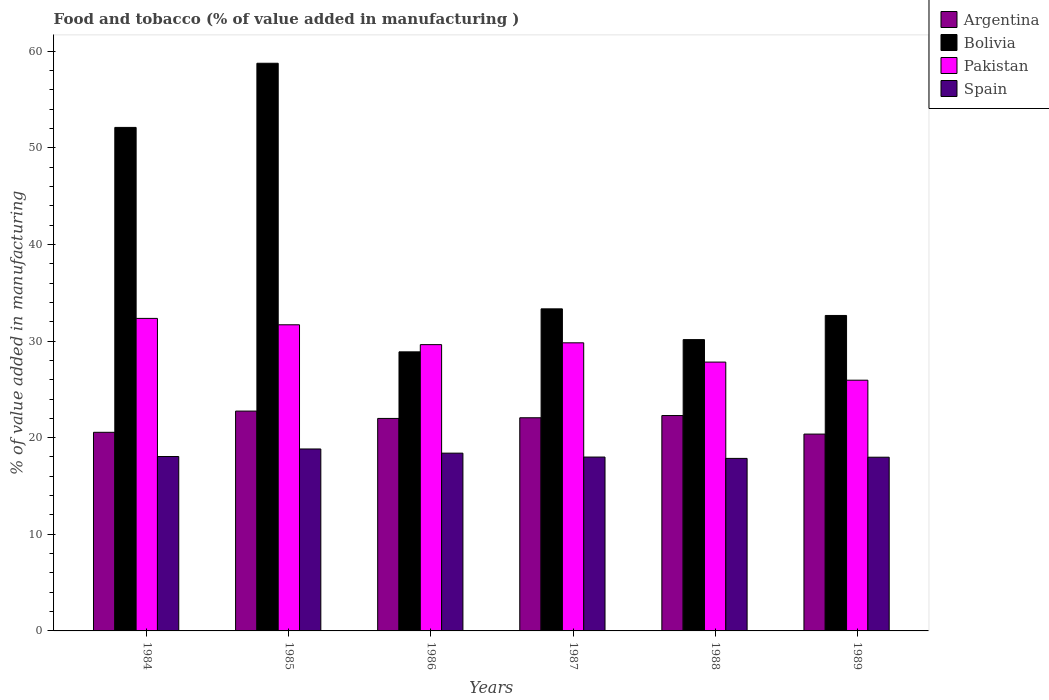How many groups of bars are there?
Give a very brief answer. 6. Are the number of bars per tick equal to the number of legend labels?
Offer a very short reply. Yes. Are the number of bars on each tick of the X-axis equal?
Keep it short and to the point. Yes. How many bars are there on the 5th tick from the left?
Offer a terse response. 4. How many bars are there on the 5th tick from the right?
Offer a very short reply. 4. What is the value added in manufacturing food and tobacco in Bolivia in 1986?
Keep it short and to the point. 28.88. Across all years, what is the maximum value added in manufacturing food and tobacco in Bolivia?
Offer a terse response. 58.75. Across all years, what is the minimum value added in manufacturing food and tobacco in Argentina?
Keep it short and to the point. 20.37. What is the total value added in manufacturing food and tobacco in Bolivia in the graph?
Provide a short and direct response. 235.86. What is the difference between the value added in manufacturing food and tobacco in Argentina in 1984 and that in 1986?
Give a very brief answer. -1.44. What is the difference between the value added in manufacturing food and tobacco in Argentina in 1988 and the value added in manufacturing food and tobacco in Pakistan in 1984?
Your response must be concise. -10.05. What is the average value added in manufacturing food and tobacco in Argentina per year?
Ensure brevity in your answer.  21.67. In the year 1986, what is the difference between the value added in manufacturing food and tobacco in Pakistan and value added in manufacturing food and tobacco in Argentina?
Your answer should be compact. 7.64. In how many years, is the value added in manufacturing food and tobacco in Spain greater than 20 %?
Your answer should be compact. 0. What is the ratio of the value added in manufacturing food and tobacco in Spain in 1985 to that in 1986?
Ensure brevity in your answer.  1.02. Is the value added in manufacturing food and tobacco in Argentina in 1988 less than that in 1989?
Offer a very short reply. No. What is the difference between the highest and the second highest value added in manufacturing food and tobacco in Pakistan?
Your response must be concise. 0.66. What is the difference between the highest and the lowest value added in manufacturing food and tobacco in Bolivia?
Offer a very short reply. 29.87. Is the sum of the value added in manufacturing food and tobacco in Spain in 1984 and 1986 greater than the maximum value added in manufacturing food and tobacco in Bolivia across all years?
Provide a short and direct response. No. Is it the case that in every year, the sum of the value added in manufacturing food and tobacco in Argentina and value added in manufacturing food and tobacco in Pakistan is greater than the sum of value added in manufacturing food and tobacco in Spain and value added in manufacturing food and tobacco in Bolivia?
Offer a terse response. Yes. What does the 4th bar from the right in 1988 represents?
Keep it short and to the point. Argentina. How many bars are there?
Your answer should be compact. 24. Are all the bars in the graph horizontal?
Ensure brevity in your answer.  No. Does the graph contain grids?
Your answer should be compact. No. Where does the legend appear in the graph?
Your answer should be compact. Top right. How many legend labels are there?
Your answer should be very brief. 4. How are the legend labels stacked?
Your response must be concise. Vertical. What is the title of the graph?
Offer a very short reply. Food and tobacco (% of value added in manufacturing ). Does "Somalia" appear as one of the legend labels in the graph?
Your answer should be very brief. No. What is the label or title of the X-axis?
Keep it short and to the point. Years. What is the label or title of the Y-axis?
Offer a very short reply. % of value added in manufacturing. What is the % of value added in manufacturing in Argentina in 1984?
Provide a short and direct response. 20.55. What is the % of value added in manufacturing of Bolivia in 1984?
Offer a terse response. 52.11. What is the % of value added in manufacturing in Pakistan in 1984?
Your response must be concise. 32.34. What is the % of value added in manufacturing of Spain in 1984?
Offer a terse response. 18.05. What is the % of value added in manufacturing of Argentina in 1985?
Offer a very short reply. 22.75. What is the % of value added in manufacturing in Bolivia in 1985?
Make the answer very short. 58.75. What is the % of value added in manufacturing of Pakistan in 1985?
Provide a short and direct response. 31.68. What is the % of value added in manufacturing of Spain in 1985?
Offer a very short reply. 18.83. What is the % of value added in manufacturing in Argentina in 1986?
Ensure brevity in your answer.  21.99. What is the % of value added in manufacturing of Bolivia in 1986?
Give a very brief answer. 28.88. What is the % of value added in manufacturing of Pakistan in 1986?
Your answer should be very brief. 29.63. What is the % of value added in manufacturing in Spain in 1986?
Offer a terse response. 18.4. What is the % of value added in manufacturing of Argentina in 1987?
Keep it short and to the point. 22.06. What is the % of value added in manufacturing in Bolivia in 1987?
Give a very brief answer. 33.33. What is the % of value added in manufacturing of Pakistan in 1987?
Your answer should be compact. 29.82. What is the % of value added in manufacturing of Spain in 1987?
Keep it short and to the point. 17.99. What is the % of value added in manufacturing of Argentina in 1988?
Your answer should be very brief. 22.29. What is the % of value added in manufacturing of Bolivia in 1988?
Offer a terse response. 30.15. What is the % of value added in manufacturing of Pakistan in 1988?
Provide a succinct answer. 27.82. What is the % of value added in manufacturing in Spain in 1988?
Provide a short and direct response. 17.85. What is the % of value added in manufacturing in Argentina in 1989?
Offer a very short reply. 20.37. What is the % of value added in manufacturing in Bolivia in 1989?
Provide a short and direct response. 32.65. What is the % of value added in manufacturing of Pakistan in 1989?
Give a very brief answer. 25.95. What is the % of value added in manufacturing of Spain in 1989?
Give a very brief answer. 17.98. Across all years, what is the maximum % of value added in manufacturing of Argentina?
Offer a very short reply. 22.75. Across all years, what is the maximum % of value added in manufacturing of Bolivia?
Your response must be concise. 58.75. Across all years, what is the maximum % of value added in manufacturing of Pakistan?
Offer a very short reply. 32.34. Across all years, what is the maximum % of value added in manufacturing of Spain?
Your response must be concise. 18.83. Across all years, what is the minimum % of value added in manufacturing in Argentina?
Provide a succinct answer. 20.37. Across all years, what is the minimum % of value added in manufacturing in Bolivia?
Your answer should be very brief. 28.88. Across all years, what is the minimum % of value added in manufacturing of Pakistan?
Offer a very short reply. 25.95. Across all years, what is the minimum % of value added in manufacturing of Spain?
Provide a succinct answer. 17.85. What is the total % of value added in manufacturing of Argentina in the graph?
Your response must be concise. 130.01. What is the total % of value added in manufacturing in Bolivia in the graph?
Make the answer very short. 235.86. What is the total % of value added in manufacturing in Pakistan in the graph?
Ensure brevity in your answer.  177.24. What is the total % of value added in manufacturing in Spain in the graph?
Your answer should be very brief. 109.1. What is the difference between the % of value added in manufacturing in Argentina in 1984 and that in 1985?
Offer a very short reply. -2.2. What is the difference between the % of value added in manufacturing in Bolivia in 1984 and that in 1985?
Keep it short and to the point. -6.64. What is the difference between the % of value added in manufacturing in Pakistan in 1984 and that in 1985?
Provide a short and direct response. 0.66. What is the difference between the % of value added in manufacturing of Spain in 1984 and that in 1985?
Provide a succinct answer. -0.78. What is the difference between the % of value added in manufacturing of Argentina in 1984 and that in 1986?
Offer a terse response. -1.44. What is the difference between the % of value added in manufacturing in Bolivia in 1984 and that in 1986?
Offer a terse response. 23.23. What is the difference between the % of value added in manufacturing in Pakistan in 1984 and that in 1986?
Provide a short and direct response. 2.72. What is the difference between the % of value added in manufacturing of Spain in 1984 and that in 1986?
Provide a short and direct response. -0.35. What is the difference between the % of value added in manufacturing in Argentina in 1984 and that in 1987?
Make the answer very short. -1.51. What is the difference between the % of value added in manufacturing in Bolivia in 1984 and that in 1987?
Make the answer very short. 18.78. What is the difference between the % of value added in manufacturing in Pakistan in 1984 and that in 1987?
Keep it short and to the point. 2.53. What is the difference between the % of value added in manufacturing of Spain in 1984 and that in 1987?
Provide a succinct answer. 0.05. What is the difference between the % of value added in manufacturing of Argentina in 1984 and that in 1988?
Give a very brief answer. -1.74. What is the difference between the % of value added in manufacturing in Bolivia in 1984 and that in 1988?
Provide a succinct answer. 21.96. What is the difference between the % of value added in manufacturing in Pakistan in 1984 and that in 1988?
Make the answer very short. 4.52. What is the difference between the % of value added in manufacturing of Spain in 1984 and that in 1988?
Your response must be concise. 0.19. What is the difference between the % of value added in manufacturing in Argentina in 1984 and that in 1989?
Make the answer very short. 0.18. What is the difference between the % of value added in manufacturing in Bolivia in 1984 and that in 1989?
Your answer should be compact. 19.46. What is the difference between the % of value added in manufacturing in Pakistan in 1984 and that in 1989?
Provide a succinct answer. 6.39. What is the difference between the % of value added in manufacturing in Spain in 1984 and that in 1989?
Ensure brevity in your answer.  0.07. What is the difference between the % of value added in manufacturing of Argentina in 1985 and that in 1986?
Provide a succinct answer. 0.76. What is the difference between the % of value added in manufacturing of Bolivia in 1985 and that in 1986?
Your response must be concise. 29.87. What is the difference between the % of value added in manufacturing of Pakistan in 1985 and that in 1986?
Your response must be concise. 2.05. What is the difference between the % of value added in manufacturing in Spain in 1985 and that in 1986?
Make the answer very short. 0.43. What is the difference between the % of value added in manufacturing in Argentina in 1985 and that in 1987?
Offer a very short reply. 0.69. What is the difference between the % of value added in manufacturing of Bolivia in 1985 and that in 1987?
Offer a very short reply. 25.42. What is the difference between the % of value added in manufacturing in Pakistan in 1985 and that in 1987?
Provide a succinct answer. 1.87. What is the difference between the % of value added in manufacturing in Spain in 1985 and that in 1987?
Keep it short and to the point. 0.84. What is the difference between the % of value added in manufacturing in Argentina in 1985 and that in 1988?
Your response must be concise. 0.46. What is the difference between the % of value added in manufacturing of Bolivia in 1985 and that in 1988?
Ensure brevity in your answer.  28.6. What is the difference between the % of value added in manufacturing in Pakistan in 1985 and that in 1988?
Provide a succinct answer. 3.86. What is the difference between the % of value added in manufacturing in Spain in 1985 and that in 1988?
Give a very brief answer. 0.97. What is the difference between the % of value added in manufacturing in Argentina in 1985 and that in 1989?
Give a very brief answer. 2.38. What is the difference between the % of value added in manufacturing in Bolivia in 1985 and that in 1989?
Give a very brief answer. 26.1. What is the difference between the % of value added in manufacturing in Pakistan in 1985 and that in 1989?
Ensure brevity in your answer.  5.73. What is the difference between the % of value added in manufacturing of Spain in 1985 and that in 1989?
Offer a very short reply. 0.85. What is the difference between the % of value added in manufacturing in Argentina in 1986 and that in 1987?
Offer a very short reply. -0.07. What is the difference between the % of value added in manufacturing in Bolivia in 1986 and that in 1987?
Offer a terse response. -4.45. What is the difference between the % of value added in manufacturing of Pakistan in 1986 and that in 1987?
Ensure brevity in your answer.  -0.19. What is the difference between the % of value added in manufacturing of Spain in 1986 and that in 1987?
Your answer should be compact. 0.4. What is the difference between the % of value added in manufacturing of Argentina in 1986 and that in 1988?
Offer a terse response. -0.3. What is the difference between the % of value added in manufacturing in Bolivia in 1986 and that in 1988?
Offer a terse response. -1.27. What is the difference between the % of value added in manufacturing of Pakistan in 1986 and that in 1988?
Provide a succinct answer. 1.8. What is the difference between the % of value added in manufacturing of Spain in 1986 and that in 1988?
Keep it short and to the point. 0.54. What is the difference between the % of value added in manufacturing in Argentina in 1986 and that in 1989?
Offer a very short reply. 1.62. What is the difference between the % of value added in manufacturing of Bolivia in 1986 and that in 1989?
Offer a very short reply. -3.77. What is the difference between the % of value added in manufacturing of Pakistan in 1986 and that in 1989?
Offer a terse response. 3.68. What is the difference between the % of value added in manufacturing in Spain in 1986 and that in 1989?
Ensure brevity in your answer.  0.42. What is the difference between the % of value added in manufacturing of Argentina in 1987 and that in 1988?
Provide a short and direct response. -0.23. What is the difference between the % of value added in manufacturing of Bolivia in 1987 and that in 1988?
Keep it short and to the point. 3.18. What is the difference between the % of value added in manufacturing of Pakistan in 1987 and that in 1988?
Ensure brevity in your answer.  1.99. What is the difference between the % of value added in manufacturing of Spain in 1987 and that in 1988?
Your answer should be compact. 0.14. What is the difference between the % of value added in manufacturing of Argentina in 1987 and that in 1989?
Give a very brief answer. 1.69. What is the difference between the % of value added in manufacturing in Bolivia in 1987 and that in 1989?
Provide a short and direct response. 0.68. What is the difference between the % of value added in manufacturing of Pakistan in 1987 and that in 1989?
Your response must be concise. 3.87. What is the difference between the % of value added in manufacturing in Spain in 1987 and that in 1989?
Keep it short and to the point. 0.02. What is the difference between the % of value added in manufacturing in Argentina in 1988 and that in 1989?
Your response must be concise. 1.92. What is the difference between the % of value added in manufacturing in Bolivia in 1988 and that in 1989?
Your answer should be very brief. -2.5. What is the difference between the % of value added in manufacturing in Pakistan in 1988 and that in 1989?
Offer a terse response. 1.87. What is the difference between the % of value added in manufacturing of Spain in 1988 and that in 1989?
Offer a very short reply. -0.12. What is the difference between the % of value added in manufacturing in Argentina in 1984 and the % of value added in manufacturing in Bolivia in 1985?
Give a very brief answer. -38.19. What is the difference between the % of value added in manufacturing of Argentina in 1984 and the % of value added in manufacturing of Pakistan in 1985?
Your answer should be very brief. -11.13. What is the difference between the % of value added in manufacturing of Argentina in 1984 and the % of value added in manufacturing of Spain in 1985?
Your answer should be compact. 1.73. What is the difference between the % of value added in manufacturing in Bolivia in 1984 and the % of value added in manufacturing in Pakistan in 1985?
Offer a terse response. 20.43. What is the difference between the % of value added in manufacturing in Bolivia in 1984 and the % of value added in manufacturing in Spain in 1985?
Your response must be concise. 33.28. What is the difference between the % of value added in manufacturing of Pakistan in 1984 and the % of value added in manufacturing of Spain in 1985?
Provide a succinct answer. 13.51. What is the difference between the % of value added in manufacturing in Argentina in 1984 and the % of value added in manufacturing in Bolivia in 1986?
Give a very brief answer. -8.33. What is the difference between the % of value added in manufacturing of Argentina in 1984 and the % of value added in manufacturing of Pakistan in 1986?
Give a very brief answer. -9.07. What is the difference between the % of value added in manufacturing in Argentina in 1984 and the % of value added in manufacturing in Spain in 1986?
Keep it short and to the point. 2.16. What is the difference between the % of value added in manufacturing in Bolivia in 1984 and the % of value added in manufacturing in Pakistan in 1986?
Your answer should be compact. 22.48. What is the difference between the % of value added in manufacturing of Bolivia in 1984 and the % of value added in manufacturing of Spain in 1986?
Your answer should be very brief. 33.71. What is the difference between the % of value added in manufacturing of Pakistan in 1984 and the % of value added in manufacturing of Spain in 1986?
Your response must be concise. 13.94. What is the difference between the % of value added in manufacturing in Argentina in 1984 and the % of value added in manufacturing in Bolivia in 1987?
Provide a short and direct response. -12.78. What is the difference between the % of value added in manufacturing of Argentina in 1984 and the % of value added in manufacturing of Pakistan in 1987?
Give a very brief answer. -9.26. What is the difference between the % of value added in manufacturing of Argentina in 1984 and the % of value added in manufacturing of Spain in 1987?
Make the answer very short. 2.56. What is the difference between the % of value added in manufacturing of Bolivia in 1984 and the % of value added in manufacturing of Pakistan in 1987?
Your answer should be very brief. 22.29. What is the difference between the % of value added in manufacturing of Bolivia in 1984 and the % of value added in manufacturing of Spain in 1987?
Your answer should be compact. 34.11. What is the difference between the % of value added in manufacturing in Pakistan in 1984 and the % of value added in manufacturing in Spain in 1987?
Make the answer very short. 14.35. What is the difference between the % of value added in manufacturing of Argentina in 1984 and the % of value added in manufacturing of Bolivia in 1988?
Ensure brevity in your answer.  -9.59. What is the difference between the % of value added in manufacturing of Argentina in 1984 and the % of value added in manufacturing of Pakistan in 1988?
Make the answer very short. -7.27. What is the difference between the % of value added in manufacturing in Argentina in 1984 and the % of value added in manufacturing in Spain in 1988?
Provide a short and direct response. 2.7. What is the difference between the % of value added in manufacturing in Bolivia in 1984 and the % of value added in manufacturing in Pakistan in 1988?
Offer a very short reply. 24.29. What is the difference between the % of value added in manufacturing in Bolivia in 1984 and the % of value added in manufacturing in Spain in 1988?
Offer a terse response. 34.25. What is the difference between the % of value added in manufacturing in Pakistan in 1984 and the % of value added in manufacturing in Spain in 1988?
Ensure brevity in your answer.  14.49. What is the difference between the % of value added in manufacturing in Argentina in 1984 and the % of value added in manufacturing in Bolivia in 1989?
Offer a terse response. -12.09. What is the difference between the % of value added in manufacturing in Argentina in 1984 and the % of value added in manufacturing in Pakistan in 1989?
Offer a terse response. -5.39. What is the difference between the % of value added in manufacturing in Argentina in 1984 and the % of value added in manufacturing in Spain in 1989?
Provide a short and direct response. 2.58. What is the difference between the % of value added in manufacturing of Bolivia in 1984 and the % of value added in manufacturing of Pakistan in 1989?
Give a very brief answer. 26.16. What is the difference between the % of value added in manufacturing in Bolivia in 1984 and the % of value added in manufacturing in Spain in 1989?
Your answer should be very brief. 34.13. What is the difference between the % of value added in manufacturing of Pakistan in 1984 and the % of value added in manufacturing of Spain in 1989?
Make the answer very short. 14.37. What is the difference between the % of value added in manufacturing in Argentina in 1985 and the % of value added in manufacturing in Bolivia in 1986?
Your response must be concise. -6.13. What is the difference between the % of value added in manufacturing in Argentina in 1985 and the % of value added in manufacturing in Pakistan in 1986?
Offer a terse response. -6.88. What is the difference between the % of value added in manufacturing of Argentina in 1985 and the % of value added in manufacturing of Spain in 1986?
Offer a very short reply. 4.35. What is the difference between the % of value added in manufacturing in Bolivia in 1985 and the % of value added in manufacturing in Pakistan in 1986?
Offer a terse response. 29.12. What is the difference between the % of value added in manufacturing in Bolivia in 1985 and the % of value added in manufacturing in Spain in 1986?
Your answer should be compact. 40.35. What is the difference between the % of value added in manufacturing in Pakistan in 1985 and the % of value added in manufacturing in Spain in 1986?
Your answer should be very brief. 13.28. What is the difference between the % of value added in manufacturing in Argentina in 1985 and the % of value added in manufacturing in Bolivia in 1987?
Ensure brevity in your answer.  -10.58. What is the difference between the % of value added in manufacturing in Argentina in 1985 and the % of value added in manufacturing in Pakistan in 1987?
Ensure brevity in your answer.  -7.07. What is the difference between the % of value added in manufacturing in Argentina in 1985 and the % of value added in manufacturing in Spain in 1987?
Your answer should be compact. 4.76. What is the difference between the % of value added in manufacturing in Bolivia in 1985 and the % of value added in manufacturing in Pakistan in 1987?
Your response must be concise. 28.93. What is the difference between the % of value added in manufacturing in Bolivia in 1985 and the % of value added in manufacturing in Spain in 1987?
Offer a terse response. 40.75. What is the difference between the % of value added in manufacturing of Pakistan in 1985 and the % of value added in manufacturing of Spain in 1987?
Ensure brevity in your answer.  13.69. What is the difference between the % of value added in manufacturing in Argentina in 1985 and the % of value added in manufacturing in Bolivia in 1988?
Give a very brief answer. -7.4. What is the difference between the % of value added in manufacturing in Argentina in 1985 and the % of value added in manufacturing in Pakistan in 1988?
Give a very brief answer. -5.07. What is the difference between the % of value added in manufacturing in Argentina in 1985 and the % of value added in manufacturing in Spain in 1988?
Your answer should be compact. 4.9. What is the difference between the % of value added in manufacturing in Bolivia in 1985 and the % of value added in manufacturing in Pakistan in 1988?
Your answer should be compact. 30.92. What is the difference between the % of value added in manufacturing in Bolivia in 1985 and the % of value added in manufacturing in Spain in 1988?
Provide a short and direct response. 40.89. What is the difference between the % of value added in manufacturing of Pakistan in 1985 and the % of value added in manufacturing of Spain in 1988?
Provide a short and direct response. 13.83. What is the difference between the % of value added in manufacturing in Argentina in 1985 and the % of value added in manufacturing in Bolivia in 1989?
Offer a terse response. -9.9. What is the difference between the % of value added in manufacturing of Argentina in 1985 and the % of value added in manufacturing of Pakistan in 1989?
Offer a terse response. -3.2. What is the difference between the % of value added in manufacturing of Argentina in 1985 and the % of value added in manufacturing of Spain in 1989?
Ensure brevity in your answer.  4.77. What is the difference between the % of value added in manufacturing of Bolivia in 1985 and the % of value added in manufacturing of Pakistan in 1989?
Your answer should be very brief. 32.8. What is the difference between the % of value added in manufacturing of Bolivia in 1985 and the % of value added in manufacturing of Spain in 1989?
Offer a very short reply. 40.77. What is the difference between the % of value added in manufacturing of Pakistan in 1985 and the % of value added in manufacturing of Spain in 1989?
Make the answer very short. 13.7. What is the difference between the % of value added in manufacturing of Argentina in 1986 and the % of value added in manufacturing of Bolivia in 1987?
Offer a terse response. -11.34. What is the difference between the % of value added in manufacturing in Argentina in 1986 and the % of value added in manufacturing in Pakistan in 1987?
Provide a short and direct response. -7.83. What is the difference between the % of value added in manufacturing in Argentina in 1986 and the % of value added in manufacturing in Spain in 1987?
Your answer should be compact. 4. What is the difference between the % of value added in manufacturing in Bolivia in 1986 and the % of value added in manufacturing in Pakistan in 1987?
Give a very brief answer. -0.93. What is the difference between the % of value added in manufacturing of Bolivia in 1986 and the % of value added in manufacturing of Spain in 1987?
Make the answer very short. 10.89. What is the difference between the % of value added in manufacturing of Pakistan in 1986 and the % of value added in manufacturing of Spain in 1987?
Make the answer very short. 11.63. What is the difference between the % of value added in manufacturing in Argentina in 1986 and the % of value added in manufacturing in Bolivia in 1988?
Offer a terse response. -8.16. What is the difference between the % of value added in manufacturing of Argentina in 1986 and the % of value added in manufacturing of Pakistan in 1988?
Provide a succinct answer. -5.83. What is the difference between the % of value added in manufacturing of Argentina in 1986 and the % of value added in manufacturing of Spain in 1988?
Offer a terse response. 4.14. What is the difference between the % of value added in manufacturing of Bolivia in 1986 and the % of value added in manufacturing of Pakistan in 1988?
Make the answer very short. 1.06. What is the difference between the % of value added in manufacturing of Bolivia in 1986 and the % of value added in manufacturing of Spain in 1988?
Ensure brevity in your answer.  11.03. What is the difference between the % of value added in manufacturing of Pakistan in 1986 and the % of value added in manufacturing of Spain in 1988?
Provide a short and direct response. 11.77. What is the difference between the % of value added in manufacturing of Argentina in 1986 and the % of value added in manufacturing of Bolivia in 1989?
Your answer should be very brief. -10.66. What is the difference between the % of value added in manufacturing in Argentina in 1986 and the % of value added in manufacturing in Pakistan in 1989?
Your answer should be very brief. -3.96. What is the difference between the % of value added in manufacturing of Argentina in 1986 and the % of value added in manufacturing of Spain in 1989?
Your response must be concise. 4.01. What is the difference between the % of value added in manufacturing in Bolivia in 1986 and the % of value added in manufacturing in Pakistan in 1989?
Provide a succinct answer. 2.93. What is the difference between the % of value added in manufacturing of Bolivia in 1986 and the % of value added in manufacturing of Spain in 1989?
Keep it short and to the point. 10.9. What is the difference between the % of value added in manufacturing of Pakistan in 1986 and the % of value added in manufacturing of Spain in 1989?
Provide a succinct answer. 11.65. What is the difference between the % of value added in manufacturing of Argentina in 1987 and the % of value added in manufacturing of Bolivia in 1988?
Your answer should be very brief. -8.09. What is the difference between the % of value added in manufacturing of Argentina in 1987 and the % of value added in manufacturing of Pakistan in 1988?
Offer a terse response. -5.76. What is the difference between the % of value added in manufacturing of Argentina in 1987 and the % of value added in manufacturing of Spain in 1988?
Offer a very short reply. 4.21. What is the difference between the % of value added in manufacturing of Bolivia in 1987 and the % of value added in manufacturing of Pakistan in 1988?
Provide a short and direct response. 5.51. What is the difference between the % of value added in manufacturing in Bolivia in 1987 and the % of value added in manufacturing in Spain in 1988?
Keep it short and to the point. 15.48. What is the difference between the % of value added in manufacturing of Pakistan in 1987 and the % of value added in manufacturing of Spain in 1988?
Your answer should be very brief. 11.96. What is the difference between the % of value added in manufacturing in Argentina in 1987 and the % of value added in manufacturing in Bolivia in 1989?
Offer a terse response. -10.59. What is the difference between the % of value added in manufacturing in Argentina in 1987 and the % of value added in manufacturing in Pakistan in 1989?
Give a very brief answer. -3.89. What is the difference between the % of value added in manufacturing of Argentina in 1987 and the % of value added in manufacturing of Spain in 1989?
Your response must be concise. 4.08. What is the difference between the % of value added in manufacturing in Bolivia in 1987 and the % of value added in manufacturing in Pakistan in 1989?
Provide a succinct answer. 7.38. What is the difference between the % of value added in manufacturing in Bolivia in 1987 and the % of value added in manufacturing in Spain in 1989?
Keep it short and to the point. 15.35. What is the difference between the % of value added in manufacturing in Pakistan in 1987 and the % of value added in manufacturing in Spain in 1989?
Ensure brevity in your answer.  11.84. What is the difference between the % of value added in manufacturing of Argentina in 1988 and the % of value added in manufacturing of Bolivia in 1989?
Provide a short and direct response. -10.36. What is the difference between the % of value added in manufacturing in Argentina in 1988 and the % of value added in manufacturing in Pakistan in 1989?
Your answer should be very brief. -3.66. What is the difference between the % of value added in manufacturing in Argentina in 1988 and the % of value added in manufacturing in Spain in 1989?
Offer a very short reply. 4.31. What is the difference between the % of value added in manufacturing in Bolivia in 1988 and the % of value added in manufacturing in Pakistan in 1989?
Provide a succinct answer. 4.2. What is the difference between the % of value added in manufacturing in Bolivia in 1988 and the % of value added in manufacturing in Spain in 1989?
Make the answer very short. 12.17. What is the difference between the % of value added in manufacturing in Pakistan in 1988 and the % of value added in manufacturing in Spain in 1989?
Offer a very short reply. 9.84. What is the average % of value added in manufacturing of Argentina per year?
Provide a succinct answer. 21.67. What is the average % of value added in manufacturing in Bolivia per year?
Make the answer very short. 39.31. What is the average % of value added in manufacturing of Pakistan per year?
Offer a very short reply. 29.54. What is the average % of value added in manufacturing of Spain per year?
Your answer should be compact. 18.18. In the year 1984, what is the difference between the % of value added in manufacturing in Argentina and % of value added in manufacturing in Bolivia?
Your response must be concise. -31.55. In the year 1984, what is the difference between the % of value added in manufacturing in Argentina and % of value added in manufacturing in Pakistan?
Provide a succinct answer. -11.79. In the year 1984, what is the difference between the % of value added in manufacturing of Argentina and % of value added in manufacturing of Spain?
Provide a short and direct response. 2.51. In the year 1984, what is the difference between the % of value added in manufacturing of Bolivia and % of value added in manufacturing of Pakistan?
Ensure brevity in your answer.  19.76. In the year 1984, what is the difference between the % of value added in manufacturing in Bolivia and % of value added in manufacturing in Spain?
Give a very brief answer. 34.06. In the year 1984, what is the difference between the % of value added in manufacturing of Pakistan and % of value added in manufacturing of Spain?
Your response must be concise. 14.29. In the year 1985, what is the difference between the % of value added in manufacturing in Argentina and % of value added in manufacturing in Bolivia?
Your answer should be very brief. -36. In the year 1985, what is the difference between the % of value added in manufacturing in Argentina and % of value added in manufacturing in Pakistan?
Make the answer very short. -8.93. In the year 1985, what is the difference between the % of value added in manufacturing in Argentina and % of value added in manufacturing in Spain?
Keep it short and to the point. 3.92. In the year 1985, what is the difference between the % of value added in manufacturing of Bolivia and % of value added in manufacturing of Pakistan?
Your answer should be compact. 27.07. In the year 1985, what is the difference between the % of value added in manufacturing of Bolivia and % of value added in manufacturing of Spain?
Give a very brief answer. 39.92. In the year 1985, what is the difference between the % of value added in manufacturing in Pakistan and % of value added in manufacturing in Spain?
Keep it short and to the point. 12.85. In the year 1986, what is the difference between the % of value added in manufacturing of Argentina and % of value added in manufacturing of Bolivia?
Make the answer very short. -6.89. In the year 1986, what is the difference between the % of value added in manufacturing of Argentina and % of value added in manufacturing of Pakistan?
Offer a terse response. -7.64. In the year 1986, what is the difference between the % of value added in manufacturing in Argentina and % of value added in manufacturing in Spain?
Your answer should be very brief. 3.59. In the year 1986, what is the difference between the % of value added in manufacturing of Bolivia and % of value added in manufacturing of Pakistan?
Provide a succinct answer. -0.75. In the year 1986, what is the difference between the % of value added in manufacturing in Bolivia and % of value added in manufacturing in Spain?
Offer a very short reply. 10.48. In the year 1986, what is the difference between the % of value added in manufacturing of Pakistan and % of value added in manufacturing of Spain?
Your response must be concise. 11.23. In the year 1987, what is the difference between the % of value added in manufacturing in Argentina and % of value added in manufacturing in Bolivia?
Your response must be concise. -11.27. In the year 1987, what is the difference between the % of value added in manufacturing of Argentina and % of value added in manufacturing of Pakistan?
Give a very brief answer. -7.76. In the year 1987, what is the difference between the % of value added in manufacturing of Argentina and % of value added in manufacturing of Spain?
Your answer should be compact. 4.07. In the year 1987, what is the difference between the % of value added in manufacturing in Bolivia and % of value added in manufacturing in Pakistan?
Give a very brief answer. 3.52. In the year 1987, what is the difference between the % of value added in manufacturing of Bolivia and % of value added in manufacturing of Spain?
Your answer should be very brief. 15.34. In the year 1987, what is the difference between the % of value added in manufacturing of Pakistan and % of value added in manufacturing of Spain?
Keep it short and to the point. 11.82. In the year 1988, what is the difference between the % of value added in manufacturing in Argentina and % of value added in manufacturing in Bolivia?
Provide a short and direct response. -7.86. In the year 1988, what is the difference between the % of value added in manufacturing of Argentina and % of value added in manufacturing of Pakistan?
Ensure brevity in your answer.  -5.53. In the year 1988, what is the difference between the % of value added in manufacturing of Argentina and % of value added in manufacturing of Spain?
Offer a terse response. 4.44. In the year 1988, what is the difference between the % of value added in manufacturing of Bolivia and % of value added in manufacturing of Pakistan?
Your response must be concise. 2.32. In the year 1988, what is the difference between the % of value added in manufacturing of Bolivia and % of value added in manufacturing of Spain?
Your answer should be compact. 12.29. In the year 1988, what is the difference between the % of value added in manufacturing in Pakistan and % of value added in manufacturing in Spain?
Offer a terse response. 9.97. In the year 1989, what is the difference between the % of value added in manufacturing in Argentina and % of value added in manufacturing in Bolivia?
Give a very brief answer. -12.28. In the year 1989, what is the difference between the % of value added in manufacturing in Argentina and % of value added in manufacturing in Pakistan?
Make the answer very short. -5.58. In the year 1989, what is the difference between the % of value added in manufacturing in Argentina and % of value added in manufacturing in Spain?
Offer a very short reply. 2.39. In the year 1989, what is the difference between the % of value added in manufacturing of Bolivia and % of value added in manufacturing of Pakistan?
Give a very brief answer. 6.7. In the year 1989, what is the difference between the % of value added in manufacturing of Bolivia and % of value added in manufacturing of Spain?
Your response must be concise. 14.67. In the year 1989, what is the difference between the % of value added in manufacturing in Pakistan and % of value added in manufacturing in Spain?
Provide a succinct answer. 7.97. What is the ratio of the % of value added in manufacturing in Argentina in 1984 to that in 1985?
Provide a succinct answer. 0.9. What is the ratio of the % of value added in manufacturing in Bolivia in 1984 to that in 1985?
Make the answer very short. 0.89. What is the ratio of the % of value added in manufacturing in Pakistan in 1984 to that in 1985?
Provide a succinct answer. 1.02. What is the ratio of the % of value added in manufacturing of Spain in 1984 to that in 1985?
Offer a terse response. 0.96. What is the ratio of the % of value added in manufacturing of Argentina in 1984 to that in 1986?
Your answer should be compact. 0.93. What is the ratio of the % of value added in manufacturing of Bolivia in 1984 to that in 1986?
Provide a short and direct response. 1.8. What is the ratio of the % of value added in manufacturing of Pakistan in 1984 to that in 1986?
Your answer should be very brief. 1.09. What is the ratio of the % of value added in manufacturing in Argentina in 1984 to that in 1987?
Keep it short and to the point. 0.93. What is the ratio of the % of value added in manufacturing in Bolivia in 1984 to that in 1987?
Your answer should be very brief. 1.56. What is the ratio of the % of value added in manufacturing of Pakistan in 1984 to that in 1987?
Your answer should be very brief. 1.08. What is the ratio of the % of value added in manufacturing in Spain in 1984 to that in 1987?
Make the answer very short. 1. What is the ratio of the % of value added in manufacturing in Argentina in 1984 to that in 1988?
Give a very brief answer. 0.92. What is the ratio of the % of value added in manufacturing in Bolivia in 1984 to that in 1988?
Your response must be concise. 1.73. What is the ratio of the % of value added in manufacturing of Pakistan in 1984 to that in 1988?
Offer a very short reply. 1.16. What is the ratio of the % of value added in manufacturing of Spain in 1984 to that in 1988?
Offer a terse response. 1.01. What is the ratio of the % of value added in manufacturing of Argentina in 1984 to that in 1989?
Your answer should be compact. 1.01. What is the ratio of the % of value added in manufacturing in Bolivia in 1984 to that in 1989?
Your answer should be very brief. 1.6. What is the ratio of the % of value added in manufacturing in Pakistan in 1984 to that in 1989?
Your response must be concise. 1.25. What is the ratio of the % of value added in manufacturing of Argentina in 1985 to that in 1986?
Give a very brief answer. 1.03. What is the ratio of the % of value added in manufacturing of Bolivia in 1985 to that in 1986?
Make the answer very short. 2.03. What is the ratio of the % of value added in manufacturing of Pakistan in 1985 to that in 1986?
Offer a very short reply. 1.07. What is the ratio of the % of value added in manufacturing of Spain in 1985 to that in 1986?
Make the answer very short. 1.02. What is the ratio of the % of value added in manufacturing in Argentina in 1985 to that in 1987?
Your response must be concise. 1.03. What is the ratio of the % of value added in manufacturing in Bolivia in 1985 to that in 1987?
Give a very brief answer. 1.76. What is the ratio of the % of value added in manufacturing of Pakistan in 1985 to that in 1987?
Make the answer very short. 1.06. What is the ratio of the % of value added in manufacturing in Spain in 1985 to that in 1987?
Offer a terse response. 1.05. What is the ratio of the % of value added in manufacturing in Argentina in 1985 to that in 1988?
Give a very brief answer. 1.02. What is the ratio of the % of value added in manufacturing in Bolivia in 1985 to that in 1988?
Ensure brevity in your answer.  1.95. What is the ratio of the % of value added in manufacturing in Pakistan in 1985 to that in 1988?
Keep it short and to the point. 1.14. What is the ratio of the % of value added in manufacturing of Spain in 1985 to that in 1988?
Keep it short and to the point. 1.05. What is the ratio of the % of value added in manufacturing of Argentina in 1985 to that in 1989?
Provide a short and direct response. 1.12. What is the ratio of the % of value added in manufacturing of Bolivia in 1985 to that in 1989?
Your answer should be compact. 1.8. What is the ratio of the % of value added in manufacturing in Pakistan in 1985 to that in 1989?
Your response must be concise. 1.22. What is the ratio of the % of value added in manufacturing of Spain in 1985 to that in 1989?
Your answer should be compact. 1.05. What is the ratio of the % of value added in manufacturing in Argentina in 1986 to that in 1987?
Offer a terse response. 1. What is the ratio of the % of value added in manufacturing in Bolivia in 1986 to that in 1987?
Offer a very short reply. 0.87. What is the ratio of the % of value added in manufacturing of Pakistan in 1986 to that in 1987?
Give a very brief answer. 0.99. What is the ratio of the % of value added in manufacturing in Spain in 1986 to that in 1987?
Provide a short and direct response. 1.02. What is the ratio of the % of value added in manufacturing in Argentina in 1986 to that in 1988?
Provide a short and direct response. 0.99. What is the ratio of the % of value added in manufacturing in Bolivia in 1986 to that in 1988?
Keep it short and to the point. 0.96. What is the ratio of the % of value added in manufacturing of Pakistan in 1986 to that in 1988?
Offer a very short reply. 1.06. What is the ratio of the % of value added in manufacturing in Spain in 1986 to that in 1988?
Provide a succinct answer. 1.03. What is the ratio of the % of value added in manufacturing of Argentina in 1986 to that in 1989?
Give a very brief answer. 1.08. What is the ratio of the % of value added in manufacturing in Bolivia in 1986 to that in 1989?
Provide a succinct answer. 0.88. What is the ratio of the % of value added in manufacturing in Pakistan in 1986 to that in 1989?
Provide a succinct answer. 1.14. What is the ratio of the % of value added in manufacturing of Spain in 1986 to that in 1989?
Offer a very short reply. 1.02. What is the ratio of the % of value added in manufacturing of Bolivia in 1987 to that in 1988?
Provide a short and direct response. 1.11. What is the ratio of the % of value added in manufacturing in Pakistan in 1987 to that in 1988?
Your answer should be very brief. 1.07. What is the ratio of the % of value added in manufacturing in Argentina in 1987 to that in 1989?
Keep it short and to the point. 1.08. What is the ratio of the % of value added in manufacturing of Bolivia in 1987 to that in 1989?
Your answer should be compact. 1.02. What is the ratio of the % of value added in manufacturing of Pakistan in 1987 to that in 1989?
Give a very brief answer. 1.15. What is the ratio of the % of value added in manufacturing in Argentina in 1988 to that in 1989?
Provide a succinct answer. 1.09. What is the ratio of the % of value added in manufacturing of Bolivia in 1988 to that in 1989?
Your answer should be compact. 0.92. What is the ratio of the % of value added in manufacturing in Pakistan in 1988 to that in 1989?
Offer a terse response. 1.07. What is the ratio of the % of value added in manufacturing of Spain in 1988 to that in 1989?
Provide a short and direct response. 0.99. What is the difference between the highest and the second highest % of value added in manufacturing in Argentina?
Your answer should be very brief. 0.46. What is the difference between the highest and the second highest % of value added in manufacturing of Bolivia?
Your answer should be very brief. 6.64. What is the difference between the highest and the second highest % of value added in manufacturing in Pakistan?
Offer a very short reply. 0.66. What is the difference between the highest and the second highest % of value added in manufacturing of Spain?
Provide a succinct answer. 0.43. What is the difference between the highest and the lowest % of value added in manufacturing in Argentina?
Offer a terse response. 2.38. What is the difference between the highest and the lowest % of value added in manufacturing in Bolivia?
Your response must be concise. 29.87. What is the difference between the highest and the lowest % of value added in manufacturing in Pakistan?
Your answer should be very brief. 6.39. What is the difference between the highest and the lowest % of value added in manufacturing of Spain?
Make the answer very short. 0.97. 